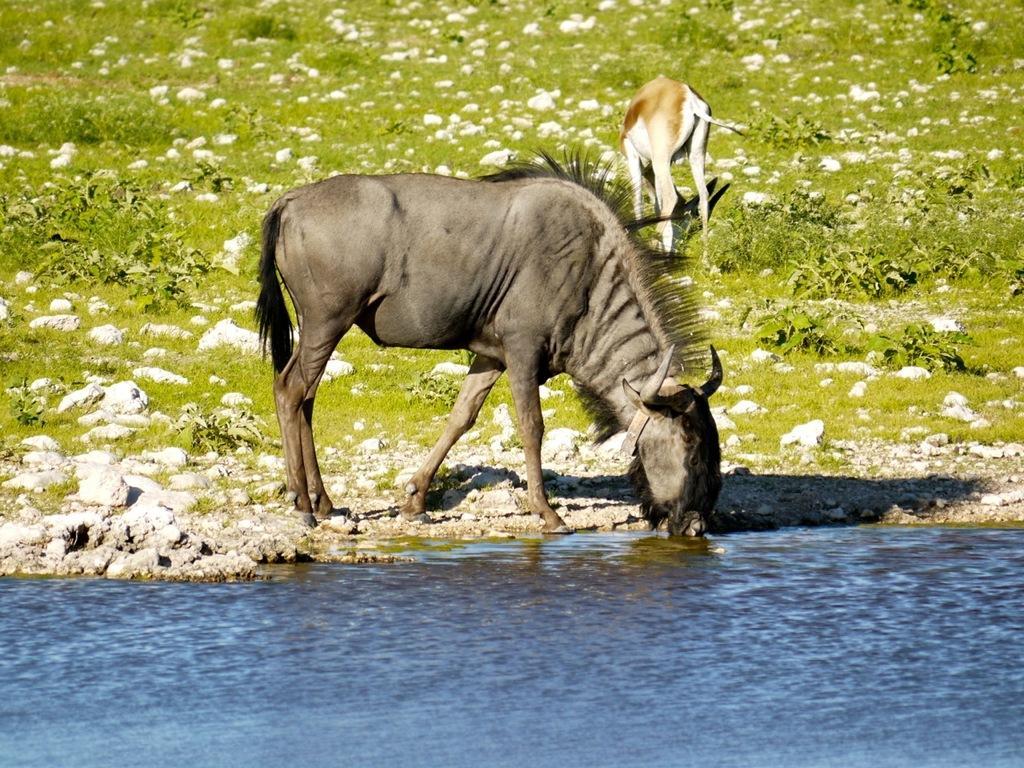Can you describe this image briefly? These are animals, this is water and plants. 